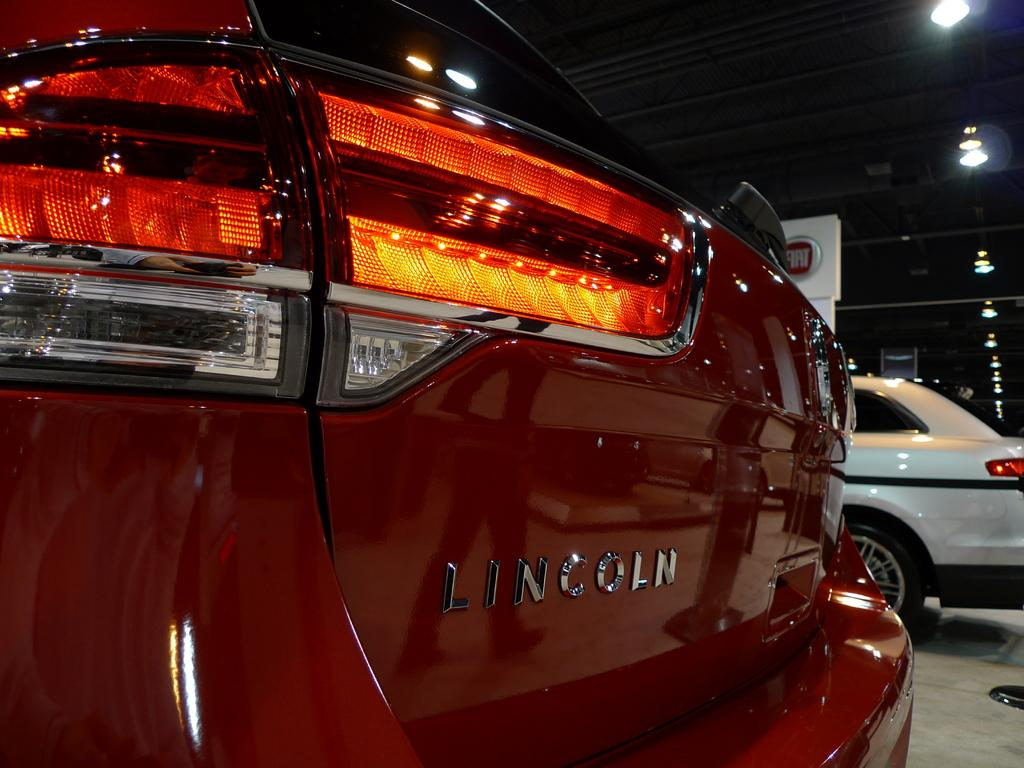What is parked on the shed in the image? There are cars parked on a shed in the image. What can be seen on the roof in the image? There are lights on the roof in the image. Where are the bells located in the image? There are no bells present in the image. What type of seat can be seen in the image? There is no seat present in the image. 